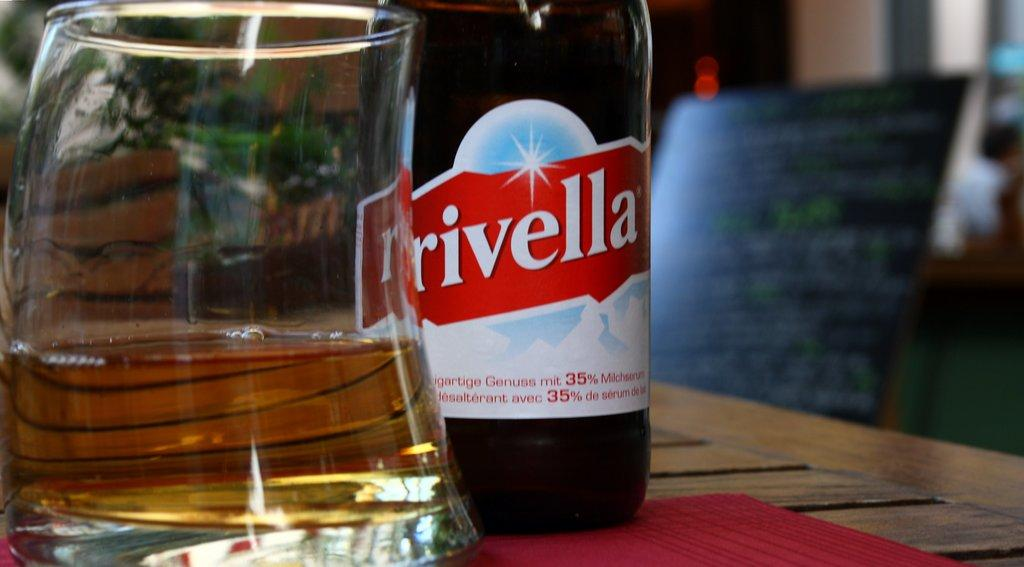<image>
Write a terse but informative summary of the picture. a bottle of red Rivella standing next to a glass 